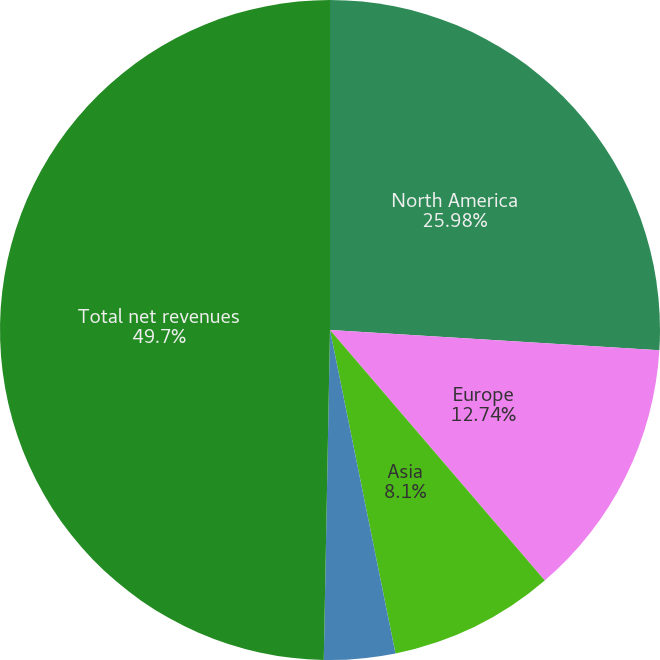Convert chart. <chart><loc_0><loc_0><loc_500><loc_500><pie_chart><fcel>North America<fcel>Europe<fcel>Asia<fcel>Other non-reportable segments<fcel>Total net revenues<nl><fcel>25.98%<fcel>12.74%<fcel>8.1%<fcel>3.48%<fcel>49.7%<nl></chart> 